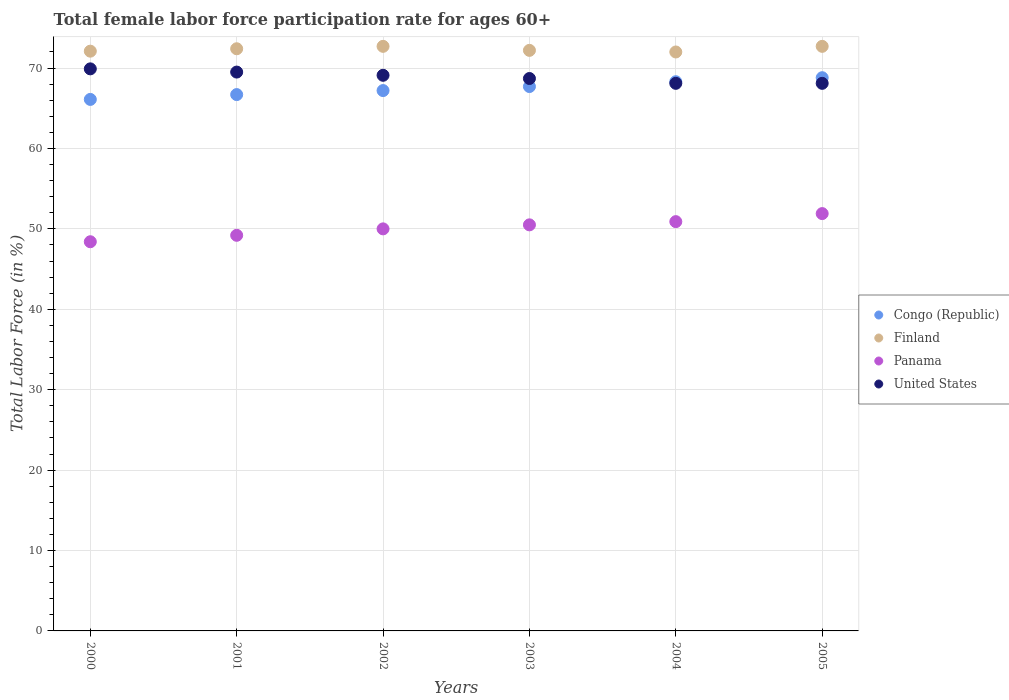How many different coloured dotlines are there?
Keep it short and to the point. 4. What is the female labor force participation rate in Finland in 2000?
Ensure brevity in your answer.  72.1. Across all years, what is the maximum female labor force participation rate in Finland?
Offer a terse response. 72.7. Across all years, what is the minimum female labor force participation rate in Finland?
Your response must be concise. 72. In which year was the female labor force participation rate in Finland maximum?
Your response must be concise. 2002. In which year was the female labor force participation rate in Congo (Republic) minimum?
Give a very brief answer. 2000. What is the total female labor force participation rate in Congo (Republic) in the graph?
Make the answer very short. 404.8. What is the difference between the female labor force participation rate in United States in 2000 and that in 2005?
Provide a succinct answer. 1.8. What is the difference between the female labor force participation rate in United States in 2005 and the female labor force participation rate in Panama in 2000?
Provide a short and direct response. 19.7. What is the average female labor force participation rate in United States per year?
Your answer should be compact. 68.9. In the year 2004, what is the difference between the female labor force participation rate in Congo (Republic) and female labor force participation rate in Panama?
Offer a very short reply. 17.4. What is the ratio of the female labor force participation rate in Finland in 2000 to that in 2004?
Your response must be concise. 1. Is the female labor force participation rate in Finland in 2000 less than that in 2003?
Your answer should be very brief. Yes. Is the difference between the female labor force participation rate in Congo (Republic) in 2000 and 2002 greater than the difference between the female labor force participation rate in Panama in 2000 and 2002?
Your answer should be compact. Yes. What is the difference between the highest and the second highest female labor force participation rate in Congo (Republic)?
Keep it short and to the point. 0.5. What is the difference between the highest and the lowest female labor force participation rate in Congo (Republic)?
Your answer should be very brief. 2.7. Is it the case that in every year, the sum of the female labor force participation rate in Finland and female labor force participation rate in United States  is greater than the sum of female labor force participation rate in Congo (Republic) and female labor force participation rate in Panama?
Your response must be concise. Yes. Is the female labor force participation rate in Finland strictly greater than the female labor force participation rate in United States over the years?
Provide a short and direct response. Yes. How many legend labels are there?
Your answer should be very brief. 4. How are the legend labels stacked?
Provide a short and direct response. Vertical. What is the title of the graph?
Give a very brief answer. Total female labor force participation rate for ages 60+. Does "United States" appear as one of the legend labels in the graph?
Give a very brief answer. Yes. What is the label or title of the X-axis?
Ensure brevity in your answer.  Years. What is the Total Labor Force (in %) of Congo (Republic) in 2000?
Offer a very short reply. 66.1. What is the Total Labor Force (in %) in Finland in 2000?
Your answer should be very brief. 72.1. What is the Total Labor Force (in %) in Panama in 2000?
Your answer should be compact. 48.4. What is the Total Labor Force (in %) of United States in 2000?
Keep it short and to the point. 69.9. What is the Total Labor Force (in %) in Congo (Republic) in 2001?
Provide a short and direct response. 66.7. What is the Total Labor Force (in %) of Finland in 2001?
Give a very brief answer. 72.4. What is the Total Labor Force (in %) in Panama in 2001?
Offer a very short reply. 49.2. What is the Total Labor Force (in %) of United States in 2001?
Give a very brief answer. 69.5. What is the Total Labor Force (in %) in Congo (Republic) in 2002?
Your response must be concise. 67.2. What is the Total Labor Force (in %) in Finland in 2002?
Give a very brief answer. 72.7. What is the Total Labor Force (in %) of United States in 2002?
Provide a short and direct response. 69.1. What is the Total Labor Force (in %) in Congo (Republic) in 2003?
Your response must be concise. 67.7. What is the Total Labor Force (in %) in Finland in 2003?
Your response must be concise. 72.2. What is the Total Labor Force (in %) of Panama in 2003?
Make the answer very short. 50.5. What is the Total Labor Force (in %) in United States in 2003?
Your response must be concise. 68.7. What is the Total Labor Force (in %) of Congo (Republic) in 2004?
Your answer should be very brief. 68.3. What is the Total Labor Force (in %) of Finland in 2004?
Provide a short and direct response. 72. What is the Total Labor Force (in %) of Panama in 2004?
Your answer should be very brief. 50.9. What is the Total Labor Force (in %) of United States in 2004?
Your answer should be compact. 68.1. What is the Total Labor Force (in %) in Congo (Republic) in 2005?
Ensure brevity in your answer.  68.8. What is the Total Labor Force (in %) in Finland in 2005?
Make the answer very short. 72.7. What is the Total Labor Force (in %) of Panama in 2005?
Keep it short and to the point. 51.9. What is the Total Labor Force (in %) of United States in 2005?
Your answer should be very brief. 68.1. Across all years, what is the maximum Total Labor Force (in %) of Congo (Republic)?
Provide a succinct answer. 68.8. Across all years, what is the maximum Total Labor Force (in %) of Finland?
Provide a succinct answer. 72.7. Across all years, what is the maximum Total Labor Force (in %) in Panama?
Keep it short and to the point. 51.9. Across all years, what is the maximum Total Labor Force (in %) in United States?
Provide a succinct answer. 69.9. Across all years, what is the minimum Total Labor Force (in %) in Congo (Republic)?
Your answer should be very brief. 66.1. Across all years, what is the minimum Total Labor Force (in %) in Panama?
Provide a succinct answer. 48.4. Across all years, what is the minimum Total Labor Force (in %) in United States?
Offer a very short reply. 68.1. What is the total Total Labor Force (in %) in Congo (Republic) in the graph?
Offer a terse response. 404.8. What is the total Total Labor Force (in %) of Finland in the graph?
Make the answer very short. 434.1. What is the total Total Labor Force (in %) in Panama in the graph?
Your response must be concise. 300.9. What is the total Total Labor Force (in %) in United States in the graph?
Offer a very short reply. 413.4. What is the difference between the Total Labor Force (in %) in Finland in 2000 and that in 2001?
Your answer should be compact. -0.3. What is the difference between the Total Labor Force (in %) in United States in 2000 and that in 2002?
Provide a short and direct response. 0.8. What is the difference between the Total Labor Force (in %) of Finland in 2000 and that in 2003?
Your response must be concise. -0.1. What is the difference between the Total Labor Force (in %) of Panama in 2000 and that in 2003?
Provide a short and direct response. -2.1. What is the difference between the Total Labor Force (in %) in Congo (Republic) in 2000 and that in 2004?
Offer a very short reply. -2.2. What is the difference between the Total Labor Force (in %) in Panama in 2000 and that in 2004?
Give a very brief answer. -2.5. What is the difference between the Total Labor Force (in %) in Panama in 2000 and that in 2005?
Offer a terse response. -3.5. What is the difference between the Total Labor Force (in %) of Congo (Republic) in 2001 and that in 2002?
Give a very brief answer. -0.5. What is the difference between the Total Labor Force (in %) of Panama in 2001 and that in 2002?
Keep it short and to the point. -0.8. What is the difference between the Total Labor Force (in %) of United States in 2001 and that in 2002?
Make the answer very short. 0.4. What is the difference between the Total Labor Force (in %) in Finland in 2001 and that in 2003?
Provide a succinct answer. 0.2. What is the difference between the Total Labor Force (in %) of Panama in 2001 and that in 2003?
Give a very brief answer. -1.3. What is the difference between the Total Labor Force (in %) in United States in 2001 and that in 2004?
Ensure brevity in your answer.  1.4. What is the difference between the Total Labor Force (in %) in Congo (Republic) in 2001 and that in 2005?
Offer a very short reply. -2.1. What is the difference between the Total Labor Force (in %) of Finland in 2002 and that in 2003?
Make the answer very short. 0.5. What is the difference between the Total Labor Force (in %) in Congo (Republic) in 2002 and that in 2004?
Offer a terse response. -1.1. What is the difference between the Total Labor Force (in %) of United States in 2002 and that in 2004?
Offer a very short reply. 1. What is the difference between the Total Labor Force (in %) in Panama in 2002 and that in 2005?
Provide a short and direct response. -1.9. What is the difference between the Total Labor Force (in %) in United States in 2002 and that in 2005?
Offer a terse response. 1. What is the difference between the Total Labor Force (in %) in Panama in 2003 and that in 2004?
Provide a short and direct response. -0.4. What is the difference between the Total Labor Force (in %) of Finland in 2003 and that in 2005?
Offer a very short reply. -0.5. What is the difference between the Total Labor Force (in %) in Panama in 2003 and that in 2005?
Give a very brief answer. -1.4. What is the difference between the Total Labor Force (in %) of Panama in 2004 and that in 2005?
Your response must be concise. -1. What is the difference between the Total Labor Force (in %) of Congo (Republic) in 2000 and the Total Labor Force (in %) of Finland in 2001?
Offer a terse response. -6.3. What is the difference between the Total Labor Force (in %) in Congo (Republic) in 2000 and the Total Labor Force (in %) in Panama in 2001?
Your answer should be very brief. 16.9. What is the difference between the Total Labor Force (in %) in Congo (Republic) in 2000 and the Total Labor Force (in %) in United States in 2001?
Offer a very short reply. -3.4. What is the difference between the Total Labor Force (in %) of Finland in 2000 and the Total Labor Force (in %) of Panama in 2001?
Your response must be concise. 22.9. What is the difference between the Total Labor Force (in %) in Panama in 2000 and the Total Labor Force (in %) in United States in 2001?
Make the answer very short. -21.1. What is the difference between the Total Labor Force (in %) in Congo (Republic) in 2000 and the Total Labor Force (in %) in Panama in 2002?
Offer a very short reply. 16.1. What is the difference between the Total Labor Force (in %) of Finland in 2000 and the Total Labor Force (in %) of Panama in 2002?
Keep it short and to the point. 22.1. What is the difference between the Total Labor Force (in %) in Panama in 2000 and the Total Labor Force (in %) in United States in 2002?
Make the answer very short. -20.7. What is the difference between the Total Labor Force (in %) in Congo (Republic) in 2000 and the Total Labor Force (in %) in Finland in 2003?
Your response must be concise. -6.1. What is the difference between the Total Labor Force (in %) of Finland in 2000 and the Total Labor Force (in %) of Panama in 2003?
Make the answer very short. 21.6. What is the difference between the Total Labor Force (in %) in Panama in 2000 and the Total Labor Force (in %) in United States in 2003?
Keep it short and to the point. -20.3. What is the difference between the Total Labor Force (in %) of Congo (Republic) in 2000 and the Total Labor Force (in %) of Finland in 2004?
Give a very brief answer. -5.9. What is the difference between the Total Labor Force (in %) in Finland in 2000 and the Total Labor Force (in %) in Panama in 2004?
Your answer should be very brief. 21.2. What is the difference between the Total Labor Force (in %) of Panama in 2000 and the Total Labor Force (in %) of United States in 2004?
Give a very brief answer. -19.7. What is the difference between the Total Labor Force (in %) in Congo (Republic) in 2000 and the Total Labor Force (in %) in Finland in 2005?
Your answer should be very brief. -6.6. What is the difference between the Total Labor Force (in %) of Finland in 2000 and the Total Labor Force (in %) of Panama in 2005?
Your answer should be compact. 20.2. What is the difference between the Total Labor Force (in %) of Finland in 2000 and the Total Labor Force (in %) of United States in 2005?
Provide a succinct answer. 4. What is the difference between the Total Labor Force (in %) in Panama in 2000 and the Total Labor Force (in %) in United States in 2005?
Your response must be concise. -19.7. What is the difference between the Total Labor Force (in %) in Congo (Republic) in 2001 and the Total Labor Force (in %) in Finland in 2002?
Your answer should be compact. -6. What is the difference between the Total Labor Force (in %) of Congo (Republic) in 2001 and the Total Labor Force (in %) of Panama in 2002?
Offer a terse response. 16.7. What is the difference between the Total Labor Force (in %) of Finland in 2001 and the Total Labor Force (in %) of Panama in 2002?
Ensure brevity in your answer.  22.4. What is the difference between the Total Labor Force (in %) of Finland in 2001 and the Total Labor Force (in %) of United States in 2002?
Make the answer very short. 3.3. What is the difference between the Total Labor Force (in %) in Panama in 2001 and the Total Labor Force (in %) in United States in 2002?
Your answer should be very brief. -19.9. What is the difference between the Total Labor Force (in %) in Congo (Republic) in 2001 and the Total Labor Force (in %) in Panama in 2003?
Give a very brief answer. 16.2. What is the difference between the Total Labor Force (in %) of Finland in 2001 and the Total Labor Force (in %) of Panama in 2003?
Give a very brief answer. 21.9. What is the difference between the Total Labor Force (in %) in Panama in 2001 and the Total Labor Force (in %) in United States in 2003?
Make the answer very short. -19.5. What is the difference between the Total Labor Force (in %) in Finland in 2001 and the Total Labor Force (in %) in United States in 2004?
Provide a succinct answer. 4.3. What is the difference between the Total Labor Force (in %) in Panama in 2001 and the Total Labor Force (in %) in United States in 2004?
Ensure brevity in your answer.  -18.9. What is the difference between the Total Labor Force (in %) in Congo (Republic) in 2001 and the Total Labor Force (in %) in Panama in 2005?
Your answer should be very brief. 14.8. What is the difference between the Total Labor Force (in %) in Congo (Republic) in 2001 and the Total Labor Force (in %) in United States in 2005?
Your answer should be very brief. -1.4. What is the difference between the Total Labor Force (in %) in Finland in 2001 and the Total Labor Force (in %) in United States in 2005?
Offer a terse response. 4.3. What is the difference between the Total Labor Force (in %) of Panama in 2001 and the Total Labor Force (in %) of United States in 2005?
Your answer should be very brief. -18.9. What is the difference between the Total Labor Force (in %) of Congo (Republic) in 2002 and the Total Labor Force (in %) of Panama in 2003?
Your answer should be compact. 16.7. What is the difference between the Total Labor Force (in %) of Congo (Republic) in 2002 and the Total Labor Force (in %) of United States in 2003?
Offer a terse response. -1.5. What is the difference between the Total Labor Force (in %) of Panama in 2002 and the Total Labor Force (in %) of United States in 2003?
Provide a succinct answer. -18.7. What is the difference between the Total Labor Force (in %) in Congo (Republic) in 2002 and the Total Labor Force (in %) in Panama in 2004?
Your answer should be very brief. 16.3. What is the difference between the Total Labor Force (in %) of Congo (Republic) in 2002 and the Total Labor Force (in %) of United States in 2004?
Give a very brief answer. -0.9. What is the difference between the Total Labor Force (in %) of Finland in 2002 and the Total Labor Force (in %) of Panama in 2004?
Ensure brevity in your answer.  21.8. What is the difference between the Total Labor Force (in %) in Finland in 2002 and the Total Labor Force (in %) in United States in 2004?
Ensure brevity in your answer.  4.6. What is the difference between the Total Labor Force (in %) of Panama in 2002 and the Total Labor Force (in %) of United States in 2004?
Offer a very short reply. -18.1. What is the difference between the Total Labor Force (in %) of Congo (Republic) in 2002 and the Total Labor Force (in %) of Finland in 2005?
Provide a short and direct response. -5.5. What is the difference between the Total Labor Force (in %) in Congo (Republic) in 2002 and the Total Labor Force (in %) in Panama in 2005?
Provide a short and direct response. 15.3. What is the difference between the Total Labor Force (in %) of Congo (Republic) in 2002 and the Total Labor Force (in %) of United States in 2005?
Give a very brief answer. -0.9. What is the difference between the Total Labor Force (in %) in Finland in 2002 and the Total Labor Force (in %) in Panama in 2005?
Provide a succinct answer. 20.8. What is the difference between the Total Labor Force (in %) in Panama in 2002 and the Total Labor Force (in %) in United States in 2005?
Make the answer very short. -18.1. What is the difference between the Total Labor Force (in %) in Congo (Republic) in 2003 and the Total Labor Force (in %) in Finland in 2004?
Offer a terse response. -4.3. What is the difference between the Total Labor Force (in %) in Finland in 2003 and the Total Labor Force (in %) in Panama in 2004?
Provide a short and direct response. 21.3. What is the difference between the Total Labor Force (in %) in Panama in 2003 and the Total Labor Force (in %) in United States in 2004?
Your response must be concise. -17.6. What is the difference between the Total Labor Force (in %) in Congo (Republic) in 2003 and the Total Labor Force (in %) in Finland in 2005?
Provide a short and direct response. -5. What is the difference between the Total Labor Force (in %) of Congo (Republic) in 2003 and the Total Labor Force (in %) of Panama in 2005?
Ensure brevity in your answer.  15.8. What is the difference between the Total Labor Force (in %) of Finland in 2003 and the Total Labor Force (in %) of Panama in 2005?
Offer a terse response. 20.3. What is the difference between the Total Labor Force (in %) in Finland in 2003 and the Total Labor Force (in %) in United States in 2005?
Your answer should be very brief. 4.1. What is the difference between the Total Labor Force (in %) in Panama in 2003 and the Total Labor Force (in %) in United States in 2005?
Your answer should be compact. -17.6. What is the difference between the Total Labor Force (in %) of Congo (Republic) in 2004 and the Total Labor Force (in %) of United States in 2005?
Offer a very short reply. 0.2. What is the difference between the Total Labor Force (in %) in Finland in 2004 and the Total Labor Force (in %) in Panama in 2005?
Offer a terse response. 20.1. What is the difference between the Total Labor Force (in %) in Finland in 2004 and the Total Labor Force (in %) in United States in 2005?
Make the answer very short. 3.9. What is the difference between the Total Labor Force (in %) of Panama in 2004 and the Total Labor Force (in %) of United States in 2005?
Offer a very short reply. -17.2. What is the average Total Labor Force (in %) in Congo (Republic) per year?
Give a very brief answer. 67.47. What is the average Total Labor Force (in %) in Finland per year?
Ensure brevity in your answer.  72.35. What is the average Total Labor Force (in %) of Panama per year?
Make the answer very short. 50.15. What is the average Total Labor Force (in %) of United States per year?
Give a very brief answer. 68.9. In the year 2000, what is the difference between the Total Labor Force (in %) of Congo (Republic) and Total Labor Force (in %) of Finland?
Give a very brief answer. -6. In the year 2000, what is the difference between the Total Labor Force (in %) of Congo (Republic) and Total Labor Force (in %) of United States?
Make the answer very short. -3.8. In the year 2000, what is the difference between the Total Labor Force (in %) of Finland and Total Labor Force (in %) of Panama?
Ensure brevity in your answer.  23.7. In the year 2000, what is the difference between the Total Labor Force (in %) in Panama and Total Labor Force (in %) in United States?
Offer a very short reply. -21.5. In the year 2001, what is the difference between the Total Labor Force (in %) in Congo (Republic) and Total Labor Force (in %) in Finland?
Provide a succinct answer. -5.7. In the year 2001, what is the difference between the Total Labor Force (in %) of Congo (Republic) and Total Labor Force (in %) of Panama?
Ensure brevity in your answer.  17.5. In the year 2001, what is the difference between the Total Labor Force (in %) in Finland and Total Labor Force (in %) in Panama?
Keep it short and to the point. 23.2. In the year 2001, what is the difference between the Total Labor Force (in %) in Panama and Total Labor Force (in %) in United States?
Your answer should be very brief. -20.3. In the year 2002, what is the difference between the Total Labor Force (in %) of Congo (Republic) and Total Labor Force (in %) of Finland?
Offer a terse response. -5.5. In the year 2002, what is the difference between the Total Labor Force (in %) in Finland and Total Labor Force (in %) in Panama?
Your response must be concise. 22.7. In the year 2002, what is the difference between the Total Labor Force (in %) of Finland and Total Labor Force (in %) of United States?
Provide a short and direct response. 3.6. In the year 2002, what is the difference between the Total Labor Force (in %) in Panama and Total Labor Force (in %) in United States?
Make the answer very short. -19.1. In the year 2003, what is the difference between the Total Labor Force (in %) in Congo (Republic) and Total Labor Force (in %) in Panama?
Provide a short and direct response. 17.2. In the year 2003, what is the difference between the Total Labor Force (in %) in Finland and Total Labor Force (in %) in Panama?
Keep it short and to the point. 21.7. In the year 2003, what is the difference between the Total Labor Force (in %) in Finland and Total Labor Force (in %) in United States?
Your answer should be compact. 3.5. In the year 2003, what is the difference between the Total Labor Force (in %) of Panama and Total Labor Force (in %) of United States?
Provide a short and direct response. -18.2. In the year 2004, what is the difference between the Total Labor Force (in %) of Congo (Republic) and Total Labor Force (in %) of Finland?
Offer a very short reply. -3.7. In the year 2004, what is the difference between the Total Labor Force (in %) in Congo (Republic) and Total Labor Force (in %) in Panama?
Make the answer very short. 17.4. In the year 2004, what is the difference between the Total Labor Force (in %) of Finland and Total Labor Force (in %) of Panama?
Provide a succinct answer. 21.1. In the year 2004, what is the difference between the Total Labor Force (in %) of Finland and Total Labor Force (in %) of United States?
Your answer should be very brief. 3.9. In the year 2004, what is the difference between the Total Labor Force (in %) in Panama and Total Labor Force (in %) in United States?
Your response must be concise. -17.2. In the year 2005, what is the difference between the Total Labor Force (in %) of Congo (Republic) and Total Labor Force (in %) of Finland?
Make the answer very short. -3.9. In the year 2005, what is the difference between the Total Labor Force (in %) in Congo (Republic) and Total Labor Force (in %) in Panama?
Make the answer very short. 16.9. In the year 2005, what is the difference between the Total Labor Force (in %) in Finland and Total Labor Force (in %) in Panama?
Make the answer very short. 20.8. In the year 2005, what is the difference between the Total Labor Force (in %) in Panama and Total Labor Force (in %) in United States?
Ensure brevity in your answer.  -16.2. What is the ratio of the Total Labor Force (in %) in Finland in 2000 to that in 2001?
Give a very brief answer. 1. What is the ratio of the Total Labor Force (in %) of Panama in 2000 to that in 2001?
Offer a very short reply. 0.98. What is the ratio of the Total Labor Force (in %) in Congo (Republic) in 2000 to that in 2002?
Offer a terse response. 0.98. What is the ratio of the Total Labor Force (in %) of Finland in 2000 to that in 2002?
Offer a terse response. 0.99. What is the ratio of the Total Labor Force (in %) in Panama in 2000 to that in 2002?
Your answer should be very brief. 0.97. What is the ratio of the Total Labor Force (in %) of United States in 2000 to that in 2002?
Give a very brief answer. 1.01. What is the ratio of the Total Labor Force (in %) in Congo (Republic) in 2000 to that in 2003?
Provide a short and direct response. 0.98. What is the ratio of the Total Labor Force (in %) in Panama in 2000 to that in 2003?
Make the answer very short. 0.96. What is the ratio of the Total Labor Force (in %) in United States in 2000 to that in 2003?
Ensure brevity in your answer.  1.02. What is the ratio of the Total Labor Force (in %) in Congo (Republic) in 2000 to that in 2004?
Offer a terse response. 0.97. What is the ratio of the Total Labor Force (in %) in Finland in 2000 to that in 2004?
Your response must be concise. 1. What is the ratio of the Total Labor Force (in %) of Panama in 2000 to that in 2004?
Offer a very short reply. 0.95. What is the ratio of the Total Labor Force (in %) of United States in 2000 to that in 2004?
Ensure brevity in your answer.  1.03. What is the ratio of the Total Labor Force (in %) in Congo (Republic) in 2000 to that in 2005?
Provide a succinct answer. 0.96. What is the ratio of the Total Labor Force (in %) in Panama in 2000 to that in 2005?
Keep it short and to the point. 0.93. What is the ratio of the Total Labor Force (in %) in United States in 2000 to that in 2005?
Offer a terse response. 1.03. What is the ratio of the Total Labor Force (in %) of Congo (Republic) in 2001 to that in 2002?
Your response must be concise. 0.99. What is the ratio of the Total Labor Force (in %) of Finland in 2001 to that in 2002?
Provide a short and direct response. 1. What is the ratio of the Total Labor Force (in %) of Congo (Republic) in 2001 to that in 2003?
Offer a very short reply. 0.99. What is the ratio of the Total Labor Force (in %) of Panama in 2001 to that in 2003?
Provide a short and direct response. 0.97. What is the ratio of the Total Labor Force (in %) in United States in 2001 to that in 2003?
Give a very brief answer. 1.01. What is the ratio of the Total Labor Force (in %) of Congo (Republic) in 2001 to that in 2004?
Ensure brevity in your answer.  0.98. What is the ratio of the Total Labor Force (in %) of Finland in 2001 to that in 2004?
Your response must be concise. 1.01. What is the ratio of the Total Labor Force (in %) in Panama in 2001 to that in 2004?
Make the answer very short. 0.97. What is the ratio of the Total Labor Force (in %) of United States in 2001 to that in 2004?
Your answer should be very brief. 1.02. What is the ratio of the Total Labor Force (in %) of Congo (Republic) in 2001 to that in 2005?
Ensure brevity in your answer.  0.97. What is the ratio of the Total Labor Force (in %) of Finland in 2001 to that in 2005?
Offer a very short reply. 1. What is the ratio of the Total Labor Force (in %) in Panama in 2001 to that in 2005?
Your response must be concise. 0.95. What is the ratio of the Total Labor Force (in %) of United States in 2001 to that in 2005?
Give a very brief answer. 1.02. What is the ratio of the Total Labor Force (in %) of Finland in 2002 to that in 2003?
Make the answer very short. 1.01. What is the ratio of the Total Labor Force (in %) in Congo (Republic) in 2002 to that in 2004?
Ensure brevity in your answer.  0.98. What is the ratio of the Total Labor Force (in %) in Finland in 2002 to that in 2004?
Keep it short and to the point. 1.01. What is the ratio of the Total Labor Force (in %) in Panama in 2002 to that in 2004?
Ensure brevity in your answer.  0.98. What is the ratio of the Total Labor Force (in %) in United States in 2002 to that in 2004?
Provide a succinct answer. 1.01. What is the ratio of the Total Labor Force (in %) of Congo (Republic) in 2002 to that in 2005?
Provide a succinct answer. 0.98. What is the ratio of the Total Labor Force (in %) of Finland in 2002 to that in 2005?
Offer a very short reply. 1. What is the ratio of the Total Labor Force (in %) of Panama in 2002 to that in 2005?
Provide a succinct answer. 0.96. What is the ratio of the Total Labor Force (in %) in United States in 2002 to that in 2005?
Provide a succinct answer. 1.01. What is the ratio of the Total Labor Force (in %) in Congo (Republic) in 2003 to that in 2004?
Offer a very short reply. 0.99. What is the ratio of the Total Labor Force (in %) in United States in 2003 to that in 2004?
Your answer should be compact. 1.01. What is the ratio of the Total Labor Force (in %) of United States in 2003 to that in 2005?
Give a very brief answer. 1.01. What is the ratio of the Total Labor Force (in %) of Congo (Republic) in 2004 to that in 2005?
Your answer should be compact. 0.99. What is the ratio of the Total Labor Force (in %) in Finland in 2004 to that in 2005?
Make the answer very short. 0.99. What is the ratio of the Total Labor Force (in %) of Panama in 2004 to that in 2005?
Give a very brief answer. 0.98. What is the difference between the highest and the second highest Total Labor Force (in %) of Congo (Republic)?
Offer a very short reply. 0.5. What is the difference between the highest and the lowest Total Labor Force (in %) in Panama?
Give a very brief answer. 3.5. What is the difference between the highest and the lowest Total Labor Force (in %) of United States?
Provide a short and direct response. 1.8. 